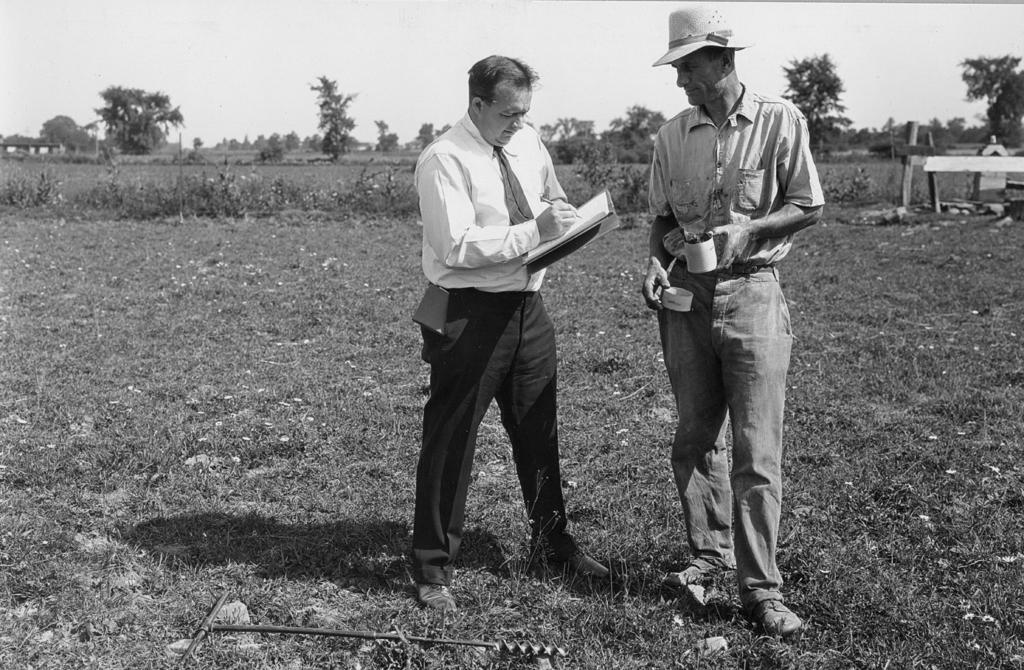How would you summarize this image in a sentence or two? In the picture I can see a person wearing white shirt is standing and writing something on a book holding in his hands and there is another person wearing hat is standing beside him and there are few plants and trees in the background. 